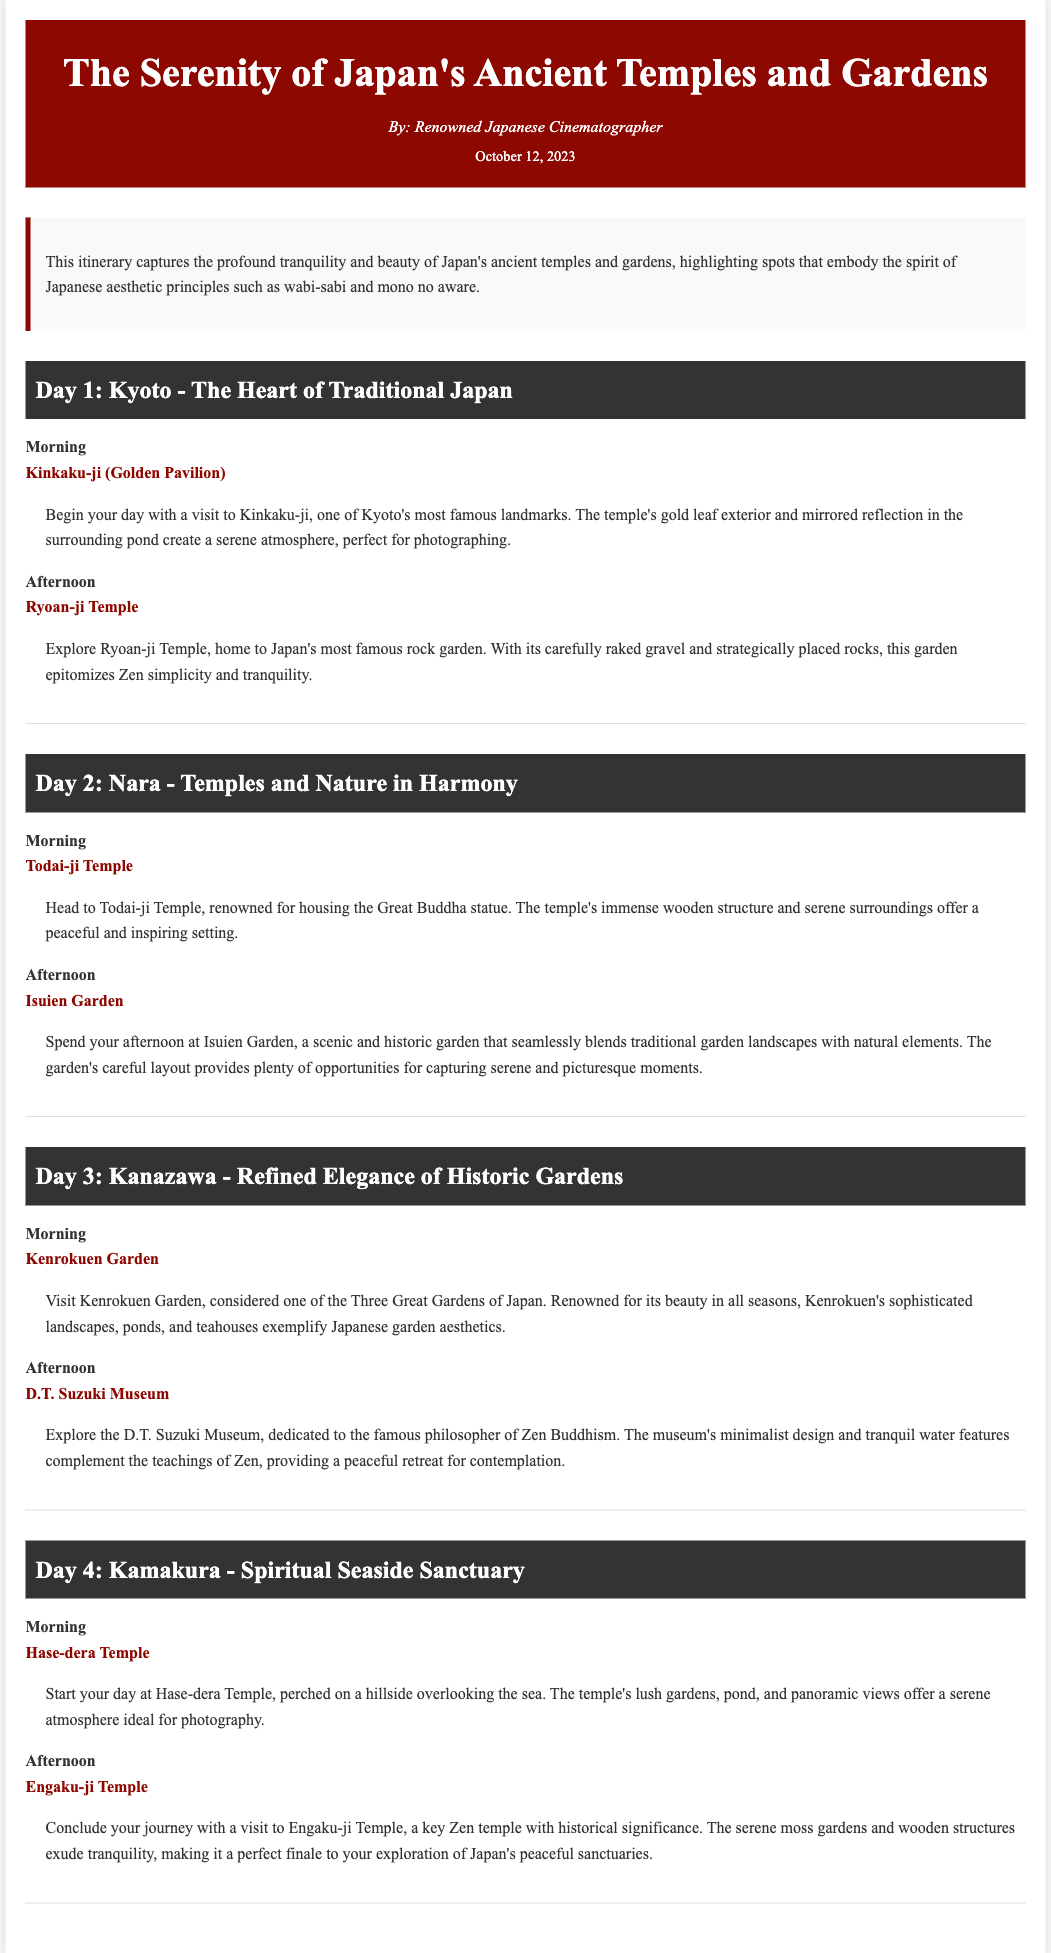What is the title of the itinerary? The title of the itinerary is explicitly stated at the top of the document.
Answer: The Serenity of Japan's Ancient Temples and Gardens Who is the author of the itinerary? The author is identified in the header section of the document.
Answer: Renowned Japanese Cinematographer What is the date of publication? The publication date is mentioned in the document.
Answer: October 12, 2023 How many days does the itinerary cover? The document describes four distinct days of activities.
Answer: 4 What is the location visited on Day 1 in the morning? The specific location for the morning of Day 1 is detailed in the itinerary.
Answer: Kinkaku-ji (Golden Pavilion) Which temple is associated with a rock garden? The document states the temple known for its rock garden in the description for Day 1.
Answer: Ryoan-ji Temple What is the primary focus of the itinerary? The overview section summarizes the main theme that encompasses the entire itinerary.
Answer: The profound tranquility and beauty of Japan's ancient temples and gardens Which garden is referred to as one of Japan's Three Great Gardens? This specific garden is mentioned in the activities for Day 3.
Answer: Kenrokuen Garden What type of museum does the D.T. Suzuki Museum represent? The type of museum is defined through its association with Zen Buddhism.
Answer: Zen Buddhism 